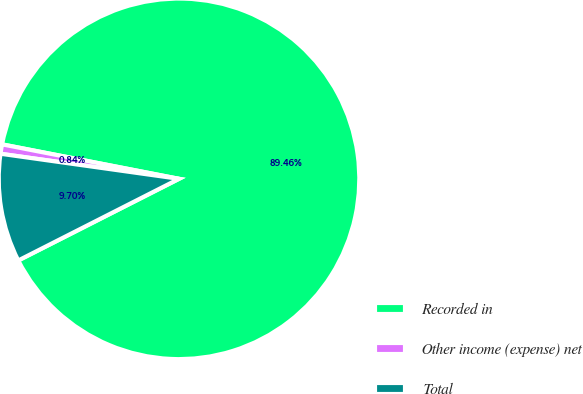Convert chart. <chart><loc_0><loc_0><loc_500><loc_500><pie_chart><fcel>Recorded in<fcel>Other income (expense) net<fcel>Total<nl><fcel>89.45%<fcel>0.84%<fcel>9.7%<nl></chart> 